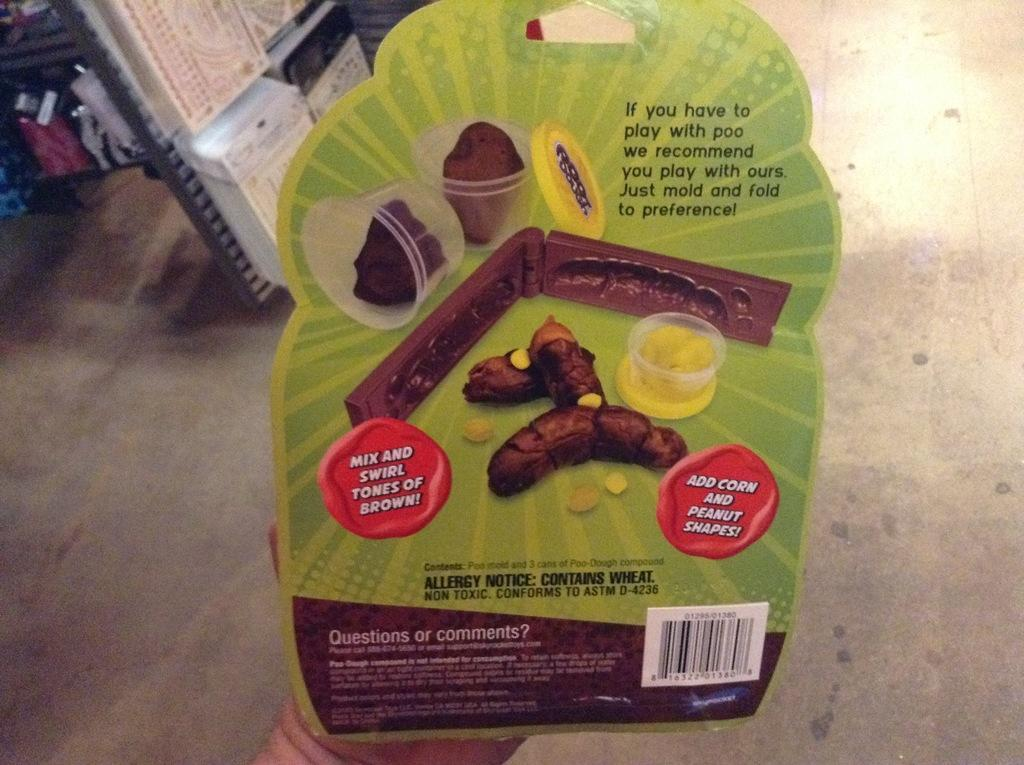What can be seen in the person's hand in the image? There is an object in the person's hand in the image. Can you describe the floor visible at the bottom of the image? The floor is visible at the bottom of the image. What type of bushes can be seen surrounding the frame of the image? There are no bushes or frame present in the image; it only shows a person's hand holding an object and a floor. 